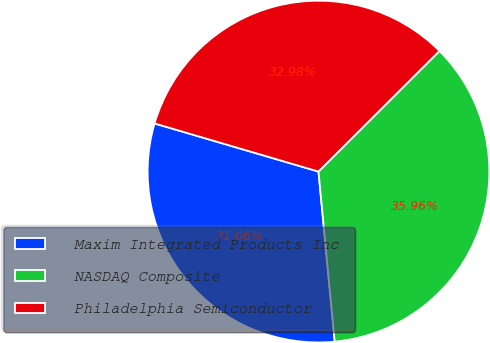Convert chart. <chart><loc_0><loc_0><loc_500><loc_500><pie_chart><fcel>Maxim Integrated Products Inc<fcel>NASDAQ Composite<fcel>Philadelphia Semiconductor<nl><fcel>31.06%<fcel>35.96%<fcel>32.98%<nl></chart> 